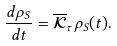<formula> <loc_0><loc_0><loc_500><loc_500>\frac { d \rho _ { S } } { d t } = \mathcal { \overline { K } } _ { \tau } \rho _ { S } ( t ) .</formula> 